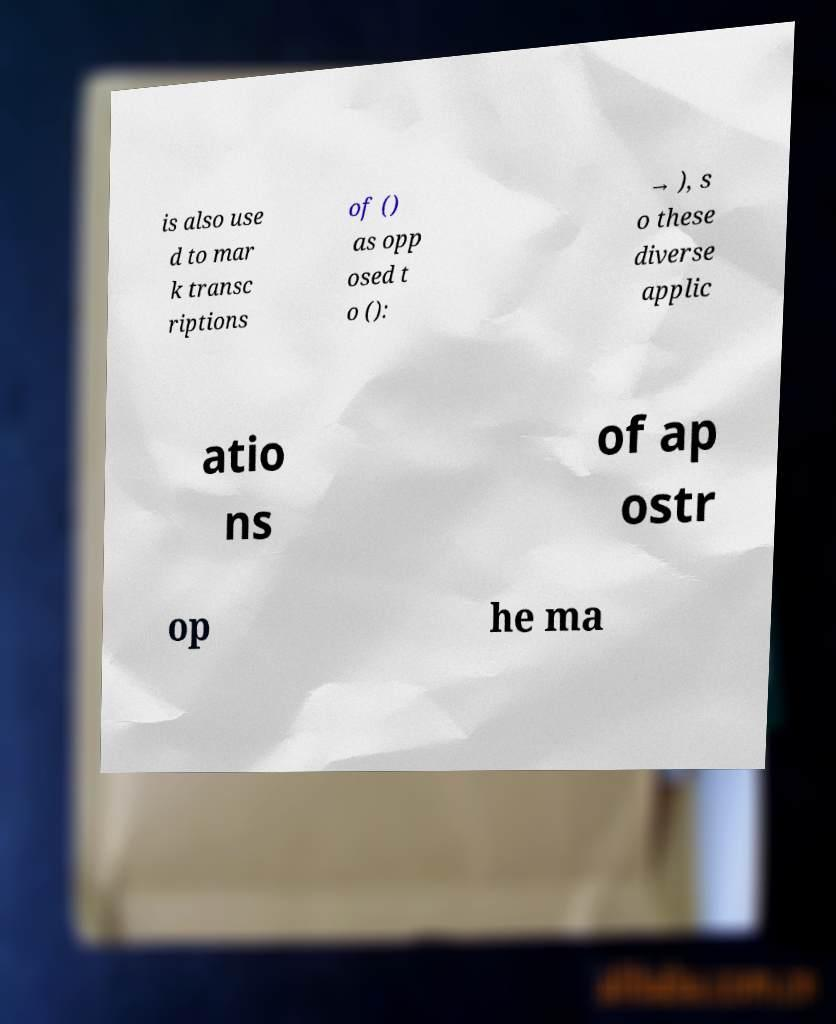Can you accurately transcribe the text from the provided image for me? is also use d to mar k transc riptions of () as opp osed t o (): → ), s o these diverse applic atio ns of ap ostr op he ma 